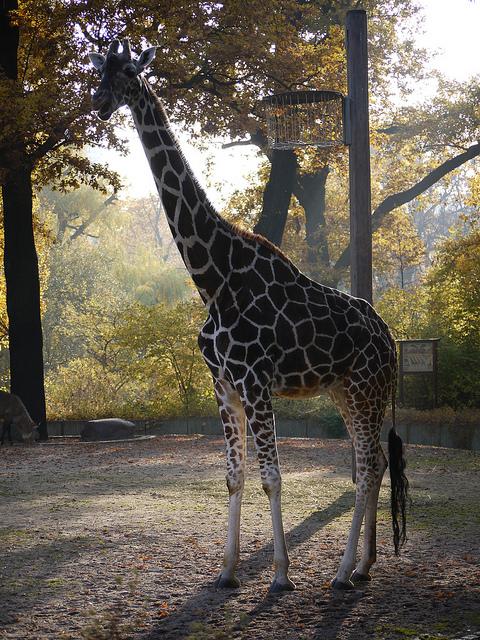How many animals are pictured here?
Short answer required. 1. Is the giraffe hungry?
Quick response, please. No. What animal is depicted in the photo?
Quick response, please. Giraffe. Is this probably a scene in the wild?
Give a very brief answer. No. 